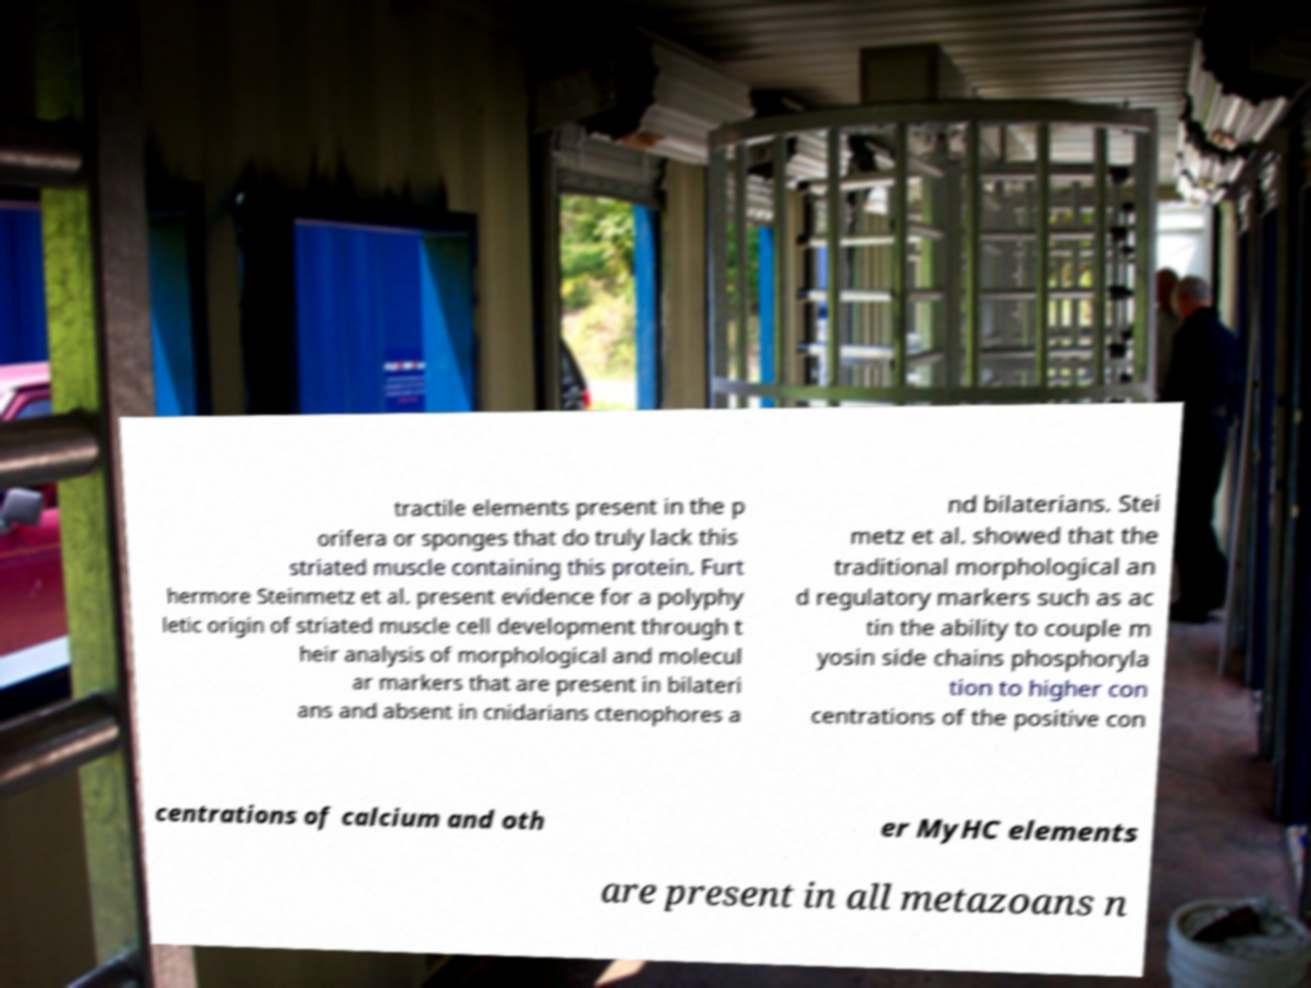For documentation purposes, I need the text within this image transcribed. Could you provide that? tractile elements present in the p orifera or sponges that do truly lack this striated muscle containing this protein. Furt hermore Steinmetz et al. present evidence for a polyphy letic origin of striated muscle cell development through t heir analysis of morphological and molecul ar markers that are present in bilateri ans and absent in cnidarians ctenophores a nd bilaterians. Stei metz et al. showed that the traditional morphological an d regulatory markers such as ac tin the ability to couple m yosin side chains phosphoryla tion to higher con centrations of the positive con centrations of calcium and oth er MyHC elements are present in all metazoans n 